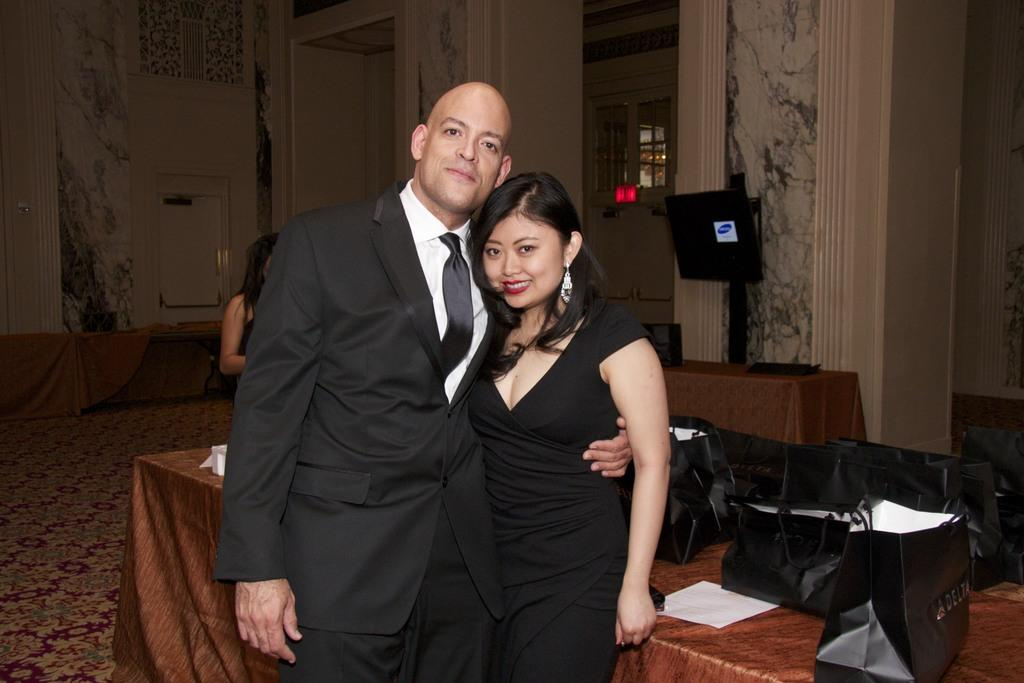Who can be seen in the image? There is a couple standing in the image. What is on the table in the image? There are covers and a paper on the table. What can be seen in the background of the image? There are screens, a door, and a wall in the background of the image. What type of loaf is being prepared in the image? There is no loaf present in the image. What is the couple's destination on their journey in the image? There is no journey depicted in the image; it simply shows a couple standing with some items on a table and a background with screens, a door, and a wall. 